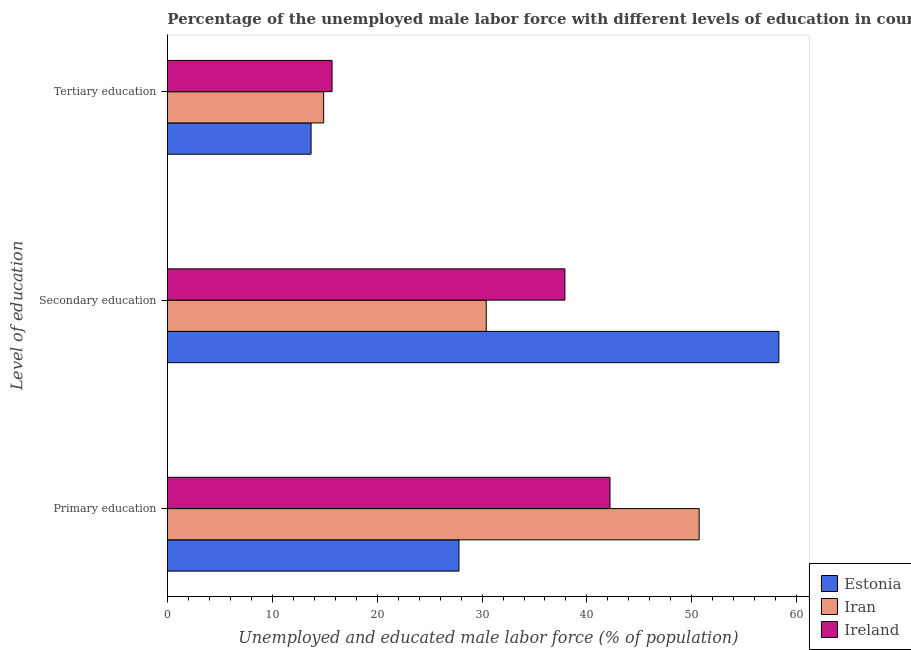Are the number of bars on each tick of the Y-axis equal?
Provide a short and direct response. Yes. What is the label of the 1st group of bars from the top?
Your response must be concise. Tertiary education. What is the percentage of male labor force who received secondary education in Iran?
Make the answer very short. 30.4. Across all countries, what is the maximum percentage of male labor force who received primary education?
Keep it short and to the point. 50.7. Across all countries, what is the minimum percentage of male labor force who received secondary education?
Offer a very short reply. 30.4. In which country was the percentage of male labor force who received tertiary education maximum?
Make the answer very short. Ireland. In which country was the percentage of male labor force who received tertiary education minimum?
Give a very brief answer. Estonia. What is the total percentage of male labor force who received primary education in the graph?
Ensure brevity in your answer.  120.7. What is the difference between the percentage of male labor force who received secondary education in Iran and that in Ireland?
Ensure brevity in your answer.  -7.5. What is the difference between the percentage of male labor force who received primary education in Ireland and the percentage of male labor force who received tertiary education in Iran?
Provide a succinct answer. 27.3. What is the average percentage of male labor force who received primary education per country?
Provide a short and direct response. 40.23. What is the difference between the percentage of male labor force who received secondary education and percentage of male labor force who received tertiary education in Ireland?
Make the answer very short. 22.2. What is the ratio of the percentage of male labor force who received secondary education in Iran to that in Ireland?
Provide a short and direct response. 0.8. What is the difference between the highest and the second highest percentage of male labor force who received secondary education?
Offer a terse response. 20.4. What does the 3rd bar from the top in Primary education represents?
Offer a very short reply. Estonia. What does the 2nd bar from the bottom in Primary education represents?
Your response must be concise. Iran. How many countries are there in the graph?
Give a very brief answer. 3. What is the difference between two consecutive major ticks on the X-axis?
Give a very brief answer. 10. Does the graph contain any zero values?
Give a very brief answer. No. Does the graph contain grids?
Offer a very short reply. No. Where does the legend appear in the graph?
Provide a short and direct response. Bottom right. What is the title of the graph?
Offer a terse response. Percentage of the unemployed male labor force with different levels of education in countries. Does "Somalia" appear as one of the legend labels in the graph?
Your answer should be compact. No. What is the label or title of the X-axis?
Your answer should be compact. Unemployed and educated male labor force (% of population). What is the label or title of the Y-axis?
Make the answer very short. Level of education. What is the Unemployed and educated male labor force (% of population) in Estonia in Primary education?
Your answer should be compact. 27.8. What is the Unemployed and educated male labor force (% of population) of Iran in Primary education?
Offer a terse response. 50.7. What is the Unemployed and educated male labor force (% of population) of Ireland in Primary education?
Your answer should be compact. 42.2. What is the Unemployed and educated male labor force (% of population) of Estonia in Secondary education?
Your response must be concise. 58.3. What is the Unemployed and educated male labor force (% of population) of Iran in Secondary education?
Keep it short and to the point. 30.4. What is the Unemployed and educated male labor force (% of population) of Ireland in Secondary education?
Offer a terse response. 37.9. What is the Unemployed and educated male labor force (% of population) in Estonia in Tertiary education?
Your answer should be very brief. 13.7. What is the Unemployed and educated male labor force (% of population) in Iran in Tertiary education?
Your response must be concise. 14.9. What is the Unemployed and educated male labor force (% of population) in Ireland in Tertiary education?
Provide a short and direct response. 15.7. Across all Level of education, what is the maximum Unemployed and educated male labor force (% of population) of Estonia?
Your answer should be compact. 58.3. Across all Level of education, what is the maximum Unemployed and educated male labor force (% of population) of Iran?
Provide a short and direct response. 50.7. Across all Level of education, what is the maximum Unemployed and educated male labor force (% of population) in Ireland?
Offer a terse response. 42.2. Across all Level of education, what is the minimum Unemployed and educated male labor force (% of population) of Estonia?
Give a very brief answer. 13.7. Across all Level of education, what is the minimum Unemployed and educated male labor force (% of population) in Iran?
Your answer should be very brief. 14.9. Across all Level of education, what is the minimum Unemployed and educated male labor force (% of population) of Ireland?
Your answer should be very brief. 15.7. What is the total Unemployed and educated male labor force (% of population) of Estonia in the graph?
Make the answer very short. 99.8. What is the total Unemployed and educated male labor force (% of population) in Iran in the graph?
Your answer should be very brief. 96. What is the total Unemployed and educated male labor force (% of population) in Ireland in the graph?
Your answer should be compact. 95.8. What is the difference between the Unemployed and educated male labor force (% of population) of Estonia in Primary education and that in Secondary education?
Provide a succinct answer. -30.5. What is the difference between the Unemployed and educated male labor force (% of population) of Iran in Primary education and that in Secondary education?
Give a very brief answer. 20.3. What is the difference between the Unemployed and educated male labor force (% of population) of Ireland in Primary education and that in Secondary education?
Your answer should be compact. 4.3. What is the difference between the Unemployed and educated male labor force (% of population) in Iran in Primary education and that in Tertiary education?
Give a very brief answer. 35.8. What is the difference between the Unemployed and educated male labor force (% of population) of Ireland in Primary education and that in Tertiary education?
Offer a terse response. 26.5. What is the difference between the Unemployed and educated male labor force (% of population) of Estonia in Secondary education and that in Tertiary education?
Offer a very short reply. 44.6. What is the difference between the Unemployed and educated male labor force (% of population) in Ireland in Secondary education and that in Tertiary education?
Offer a very short reply. 22.2. What is the difference between the Unemployed and educated male labor force (% of population) of Estonia in Primary education and the Unemployed and educated male labor force (% of population) of Iran in Secondary education?
Your answer should be very brief. -2.6. What is the difference between the Unemployed and educated male labor force (% of population) of Estonia in Primary education and the Unemployed and educated male labor force (% of population) of Ireland in Secondary education?
Ensure brevity in your answer.  -10.1. What is the difference between the Unemployed and educated male labor force (% of population) of Iran in Primary education and the Unemployed and educated male labor force (% of population) of Ireland in Tertiary education?
Offer a terse response. 35. What is the difference between the Unemployed and educated male labor force (% of population) in Estonia in Secondary education and the Unemployed and educated male labor force (% of population) in Iran in Tertiary education?
Ensure brevity in your answer.  43.4. What is the difference between the Unemployed and educated male labor force (% of population) of Estonia in Secondary education and the Unemployed and educated male labor force (% of population) of Ireland in Tertiary education?
Provide a succinct answer. 42.6. What is the difference between the Unemployed and educated male labor force (% of population) in Iran in Secondary education and the Unemployed and educated male labor force (% of population) in Ireland in Tertiary education?
Give a very brief answer. 14.7. What is the average Unemployed and educated male labor force (% of population) in Estonia per Level of education?
Give a very brief answer. 33.27. What is the average Unemployed and educated male labor force (% of population) of Iran per Level of education?
Make the answer very short. 32. What is the average Unemployed and educated male labor force (% of population) in Ireland per Level of education?
Make the answer very short. 31.93. What is the difference between the Unemployed and educated male labor force (% of population) in Estonia and Unemployed and educated male labor force (% of population) in Iran in Primary education?
Keep it short and to the point. -22.9. What is the difference between the Unemployed and educated male labor force (% of population) in Estonia and Unemployed and educated male labor force (% of population) in Ireland in Primary education?
Keep it short and to the point. -14.4. What is the difference between the Unemployed and educated male labor force (% of population) of Iran and Unemployed and educated male labor force (% of population) of Ireland in Primary education?
Keep it short and to the point. 8.5. What is the difference between the Unemployed and educated male labor force (% of population) in Estonia and Unemployed and educated male labor force (% of population) in Iran in Secondary education?
Give a very brief answer. 27.9. What is the difference between the Unemployed and educated male labor force (% of population) in Estonia and Unemployed and educated male labor force (% of population) in Ireland in Secondary education?
Ensure brevity in your answer.  20.4. What is the difference between the Unemployed and educated male labor force (% of population) in Estonia and Unemployed and educated male labor force (% of population) in Iran in Tertiary education?
Keep it short and to the point. -1.2. What is the difference between the Unemployed and educated male labor force (% of population) of Estonia and Unemployed and educated male labor force (% of population) of Ireland in Tertiary education?
Your response must be concise. -2. What is the ratio of the Unemployed and educated male labor force (% of population) of Estonia in Primary education to that in Secondary education?
Provide a succinct answer. 0.48. What is the ratio of the Unemployed and educated male labor force (% of population) in Iran in Primary education to that in Secondary education?
Ensure brevity in your answer.  1.67. What is the ratio of the Unemployed and educated male labor force (% of population) of Ireland in Primary education to that in Secondary education?
Ensure brevity in your answer.  1.11. What is the ratio of the Unemployed and educated male labor force (% of population) in Estonia in Primary education to that in Tertiary education?
Offer a very short reply. 2.03. What is the ratio of the Unemployed and educated male labor force (% of population) of Iran in Primary education to that in Tertiary education?
Your answer should be very brief. 3.4. What is the ratio of the Unemployed and educated male labor force (% of population) in Ireland in Primary education to that in Tertiary education?
Give a very brief answer. 2.69. What is the ratio of the Unemployed and educated male labor force (% of population) of Estonia in Secondary education to that in Tertiary education?
Provide a short and direct response. 4.26. What is the ratio of the Unemployed and educated male labor force (% of population) in Iran in Secondary education to that in Tertiary education?
Your answer should be compact. 2.04. What is the ratio of the Unemployed and educated male labor force (% of population) in Ireland in Secondary education to that in Tertiary education?
Make the answer very short. 2.41. What is the difference between the highest and the second highest Unemployed and educated male labor force (% of population) in Estonia?
Provide a short and direct response. 30.5. What is the difference between the highest and the second highest Unemployed and educated male labor force (% of population) in Iran?
Offer a very short reply. 20.3. What is the difference between the highest and the second highest Unemployed and educated male labor force (% of population) in Ireland?
Your response must be concise. 4.3. What is the difference between the highest and the lowest Unemployed and educated male labor force (% of population) in Estonia?
Give a very brief answer. 44.6. What is the difference between the highest and the lowest Unemployed and educated male labor force (% of population) in Iran?
Your answer should be very brief. 35.8. What is the difference between the highest and the lowest Unemployed and educated male labor force (% of population) in Ireland?
Your answer should be compact. 26.5. 